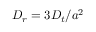Convert formula to latex. <formula><loc_0><loc_0><loc_500><loc_500>D _ { r } = 3 D _ { t } / a ^ { 2 }</formula> 